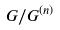Convert formula to latex. <formula><loc_0><loc_0><loc_500><loc_500>G / G ^ { ( n ) }</formula> 